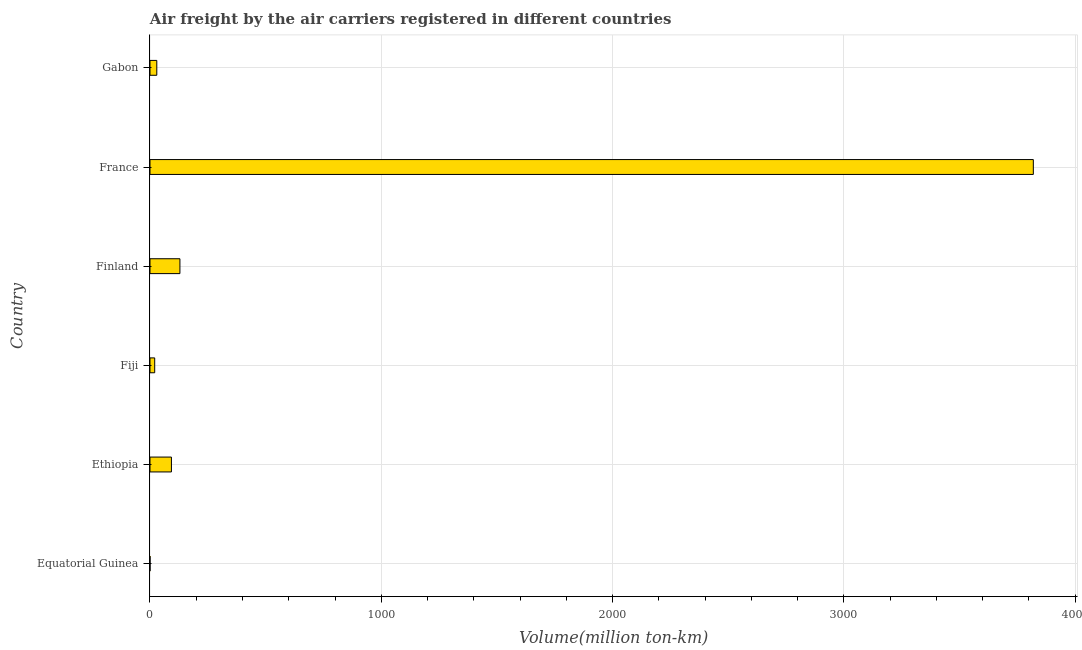Does the graph contain any zero values?
Your answer should be very brief. No. What is the title of the graph?
Offer a very short reply. Air freight by the air carriers registered in different countries. What is the label or title of the X-axis?
Provide a short and direct response. Volume(million ton-km). What is the air freight in Fiji?
Offer a terse response. 20.4. Across all countries, what is the maximum air freight?
Provide a short and direct response. 3819.3. Across all countries, what is the minimum air freight?
Your answer should be compact. 0.1. In which country was the air freight minimum?
Provide a short and direct response. Equatorial Guinea. What is the sum of the air freight?
Your answer should be compact. 4091.3. What is the average air freight per country?
Your answer should be very brief. 681.88. What is the median air freight?
Ensure brevity in your answer.  61.05. What is the ratio of the air freight in Equatorial Guinea to that in Gabon?
Your answer should be compact. 0. Is the air freight in Fiji less than that in Finland?
Give a very brief answer. Yes. What is the difference between the highest and the second highest air freight?
Offer a terse response. 3689.9. Is the sum of the air freight in Equatorial Guinea and Ethiopia greater than the maximum air freight across all countries?
Your answer should be very brief. No. What is the difference between the highest and the lowest air freight?
Offer a terse response. 3819.2. Are all the bars in the graph horizontal?
Ensure brevity in your answer.  Yes. What is the difference between two consecutive major ticks on the X-axis?
Keep it short and to the point. 1000. What is the Volume(million ton-km) in Equatorial Guinea?
Your answer should be compact. 0.1. What is the Volume(million ton-km) of Ethiopia?
Ensure brevity in your answer.  92.7. What is the Volume(million ton-km) of Fiji?
Your answer should be very brief. 20.4. What is the Volume(million ton-km) of Finland?
Ensure brevity in your answer.  129.4. What is the Volume(million ton-km) in France?
Your answer should be compact. 3819.3. What is the Volume(million ton-km) of Gabon?
Your answer should be compact. 29.4. What is the difference between the Volume(million ton-km) in Equatorial Guinea and Ethiopia?
Your answer should be very brief. -92.6. What is the difference between the Volume(million ton-km) in Equatorial Guinea and Fiji?
Your response must be concise. -20.3. What is the difference between the Volume(million ton-km) in Equatorial Guinea and Finland?
Provide a short and direct response. -129.3. What is the difference between the Volume(million ton-km) in Equatorial Guinea and France?
Ensure brevity in your answer.  -3819.2. What is the difference between the Volume(million ton-km) in Equatorial Guinea and Gabon?
Your answer should be compact. -29.3. What is the difference between the Volume(million ton-km) in Ethiopia and Fiji?
Your answer should be very brief. 72.3. What is the difference between the Volume(million ton-km) in Ethiopia and Finland?
Provide a short and direct response. -36.7. What is the difference between the Volume(million ton-km) in Ethiopia and France?
Your answer should be very brief. -3726.6. What is the difference between the Volume(million ton-km) in Ethiopia and Gabon?
Offer a very short reply. 63.3. What is the difference between the Volume(million ton-km) in Fiji and Finland?
Give a very brief answer. -109. What is the difference between the Volume(million ton-km) in Fiji and France?
Ensure brevity in your answer.  -3798.9. What is the difference between the Volume(million ton-km) in Fiji and Gabon?
Keep it short and to the point. -9. What is the difference between the Volume(million ton-km) in Finland and France?
Your answer should be very brief. -3689.9. What is the difference between the Volume(million ton-km) in Finland and Gabon?
Ensure brevity in your answer.  100. What is the difference between the Volume(million ton-km) in France and Gabon?
Make the answer very short. 3789.9. What is the ratio of the Volume(million ton-km) in Equatorial Guinea to that in Ethiopia?
Ensure brevity in your answer.  0. What is the ratio of the Volume(million ton-km) in Equatorial Guinea to that in Fiji?
Ensure brevity in your answer.  0.01. What is the ratio of the Volume(million ton-km) in Equatorial Guinea to that in Finland?
Make the answer very short. 0. What is the ratio of the Volume(million ton-km) in Equatorial Guinea to that in France?
Your response must be concise. 0. What is the ratio of the Volume(million ton-km) in Equatorial Guinea to that in Gabon?
Keep it short and to the point. 0. What is the ratio of the Volume(million ton-km) in Ethiopia to that in Fiji?
Provide a short and direct response. 4.54. What is the ratio of the Volume(million ton-km) in Ethiopia to that in Finland?
Your response must be concise. 0.72. What is the ratio of the Volume(million ton-km) in Ethiopia to that in France?
Provide a succinct answer. 0.02. What is the ratio of the Volume(million ton-km) in Ethiopia to that in Gabon?
Ensure brevity in your answer.  3.15. What is the ratio of the Volume(million ton-km) in Fiji to that in Finland?
Provide a succinct answer. 0.16. What is the ratio of the Volume(million ton-km) in Fiji to that in France?
Provide a short and direct response. 0.01. What is the ratio of the Volume(million ton-km) in Fiji to that in Gabon?
Your response must be concise. 0.69. What is the ratio of the Volume(million ton-km) in Finland to that in France?
Your answer should be very brief. 0.03. What is the ratio of the Volume(million ton-km) in Finland to that in Gabon?
Offer a terse response. 4.4. What is the ratio of the Volume(million ton-km) in France to that in Gabon?
Make the answer very short. 129.91. 